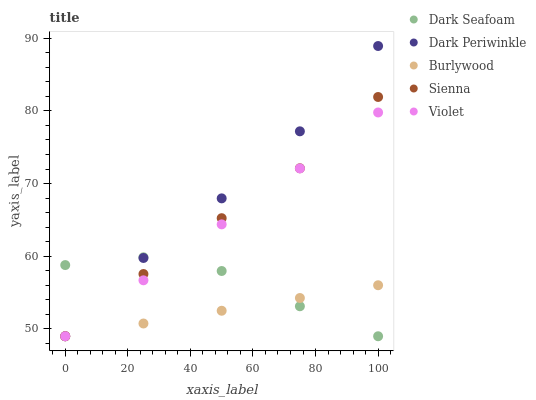Does Burlywood have the minimum area under the curve?
Answer yes or no. Yes. Does Dark Periwinkle have the maximum area under the curve?
Answer yes or no. Yes. Does Sienna have the minimum area under the curve?
Answer yes or no. No. Does Sienna have the maximum area under the curve?
Answer yes or no. No. Is Burlywood the smoothest?
Answer yes or no. Yes. Is Dark Seafoam the roughest?
Answer yes or no. Yes. Is Sienna the smoothest?
Answer yes or no. No. Is Sienna the roughest?
Answer yes or no. No. Does Burlywood have the lowest value?
Answer yes or no. Yes. Does Dark Periwinkle have the highest value?
Answer yes or no. Yes. Does Sienna have the highest value?
Answer yes or no. No. Does Dark Seafoam intersect Violet?
Answer yes or no. Yes. Is Dark Seafoam less than Violet?
Answer yes or no. No. Is Dark Seafoam greater than Violet?
Answer yes or no. No. 